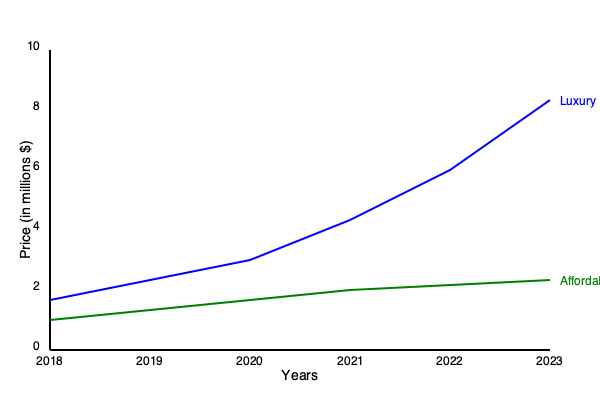Based on the graph showing price trends of luxury properties vs. affordable housing from 2018 to 2023, calculate the percentage increase in the price of luxury properties. How does this compare to the growth rate of affordable housing prices, and what implications might this have for future investments in the luxury property market? To answer this question, we need to follow these steps:

1. Calculate the percentage increase in luxury property prices:
   - Initial price (2018): $5 million
   - Final price (2023): $9 million
   - Percentage increase = $\frac{\text{Final price} - \text{Initial price}}{\text{Initial price}} \times 100\%$
   - $\frac{9 - 5}{5} \times 100\% = 80\%$

2. Calculate the percentage increase in affordable housing prices:
   - Initial price (2018): $1.6 million
   - Final price (2023): $2.4 million
   - Percentage increase = $\frac{2.4 - 1.6}{1.6} \times 100\% = 50\%$

3. Compare the growth rates:
   - Luxury properties increased by 80%
   - Affordable housing increased by 50%
   - The difference in growth rates is 30 percentage points

4. Analyze implications for future investments:
   - Luxury properties show a higher growth rate, indicating potentially higher returns
   - The steeper upward trend of luxury properties suggests continued strong demand
   - The widening gap between luxury and affordable housing prices may indicate increasing market segmentation
   - Higher growth rates in the luxury market could attract more investors, potentially driving prices even higher
   - However, the rapid price increase might also lead to concerns about a potential bubble in the luxury market

5. Consider risks:
   - The luxury market's steep growth might not be sustainable in the long term
   - Economic factors or policy changes could impact the luxury market more significantly than the affordable housing market
   - Diversification between luxury and affordable housing investments might be a prudent strategy to balance risk and return
Answer: Luxury property prices increased by 80%, outpacing affordable housing's 50% growth. This suggests potentially higher returns and strong demand in the luxury market, but also carries risks of market volatility and potential oversaturation. 